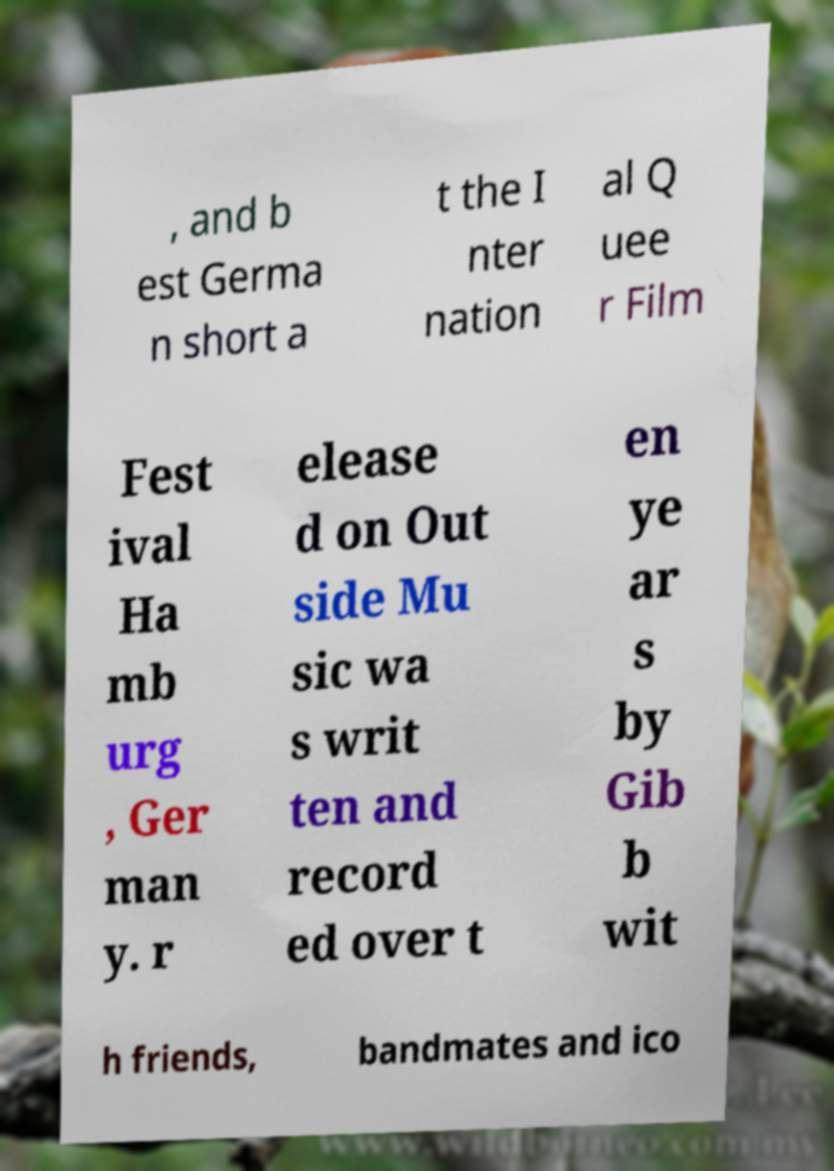I need the written content from this picture converted into text. Can you do that? , and b est Germa n short a t the I nter nation al Q uee r Film Fest ival Ha mb urg , Ger man y. r elease d on Out side Mu sic wa s writ ten and record ed over t en ye ar s by Gib b wit h friends, bandmates and ico 